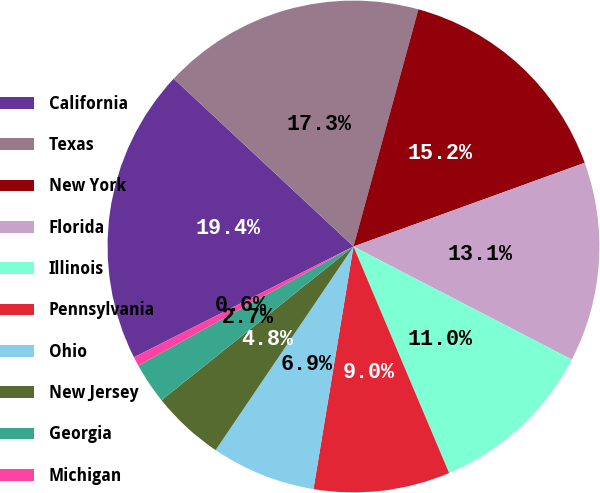Convert chart. <chart><loc_0><loc_0><loc_500><loc_500><pie_chart><fcel>California<fcel>Texas<fcel>New York<fcel>Florida<fcel>Illinois<fcel>Pennsylvania<fcel>Ohio<fcel>New Jersey<fcel>Georgia<fcel>Michigan<nl><fcel>19.39%<fcel>17.3%<fcel>15.22%<fcel>13.13%<fcel>11.04%<fcel>8.96%<fcel>6.87%<fcel>4.78%<fcel>2.7%<fcel>0.61%<nl></chart> 